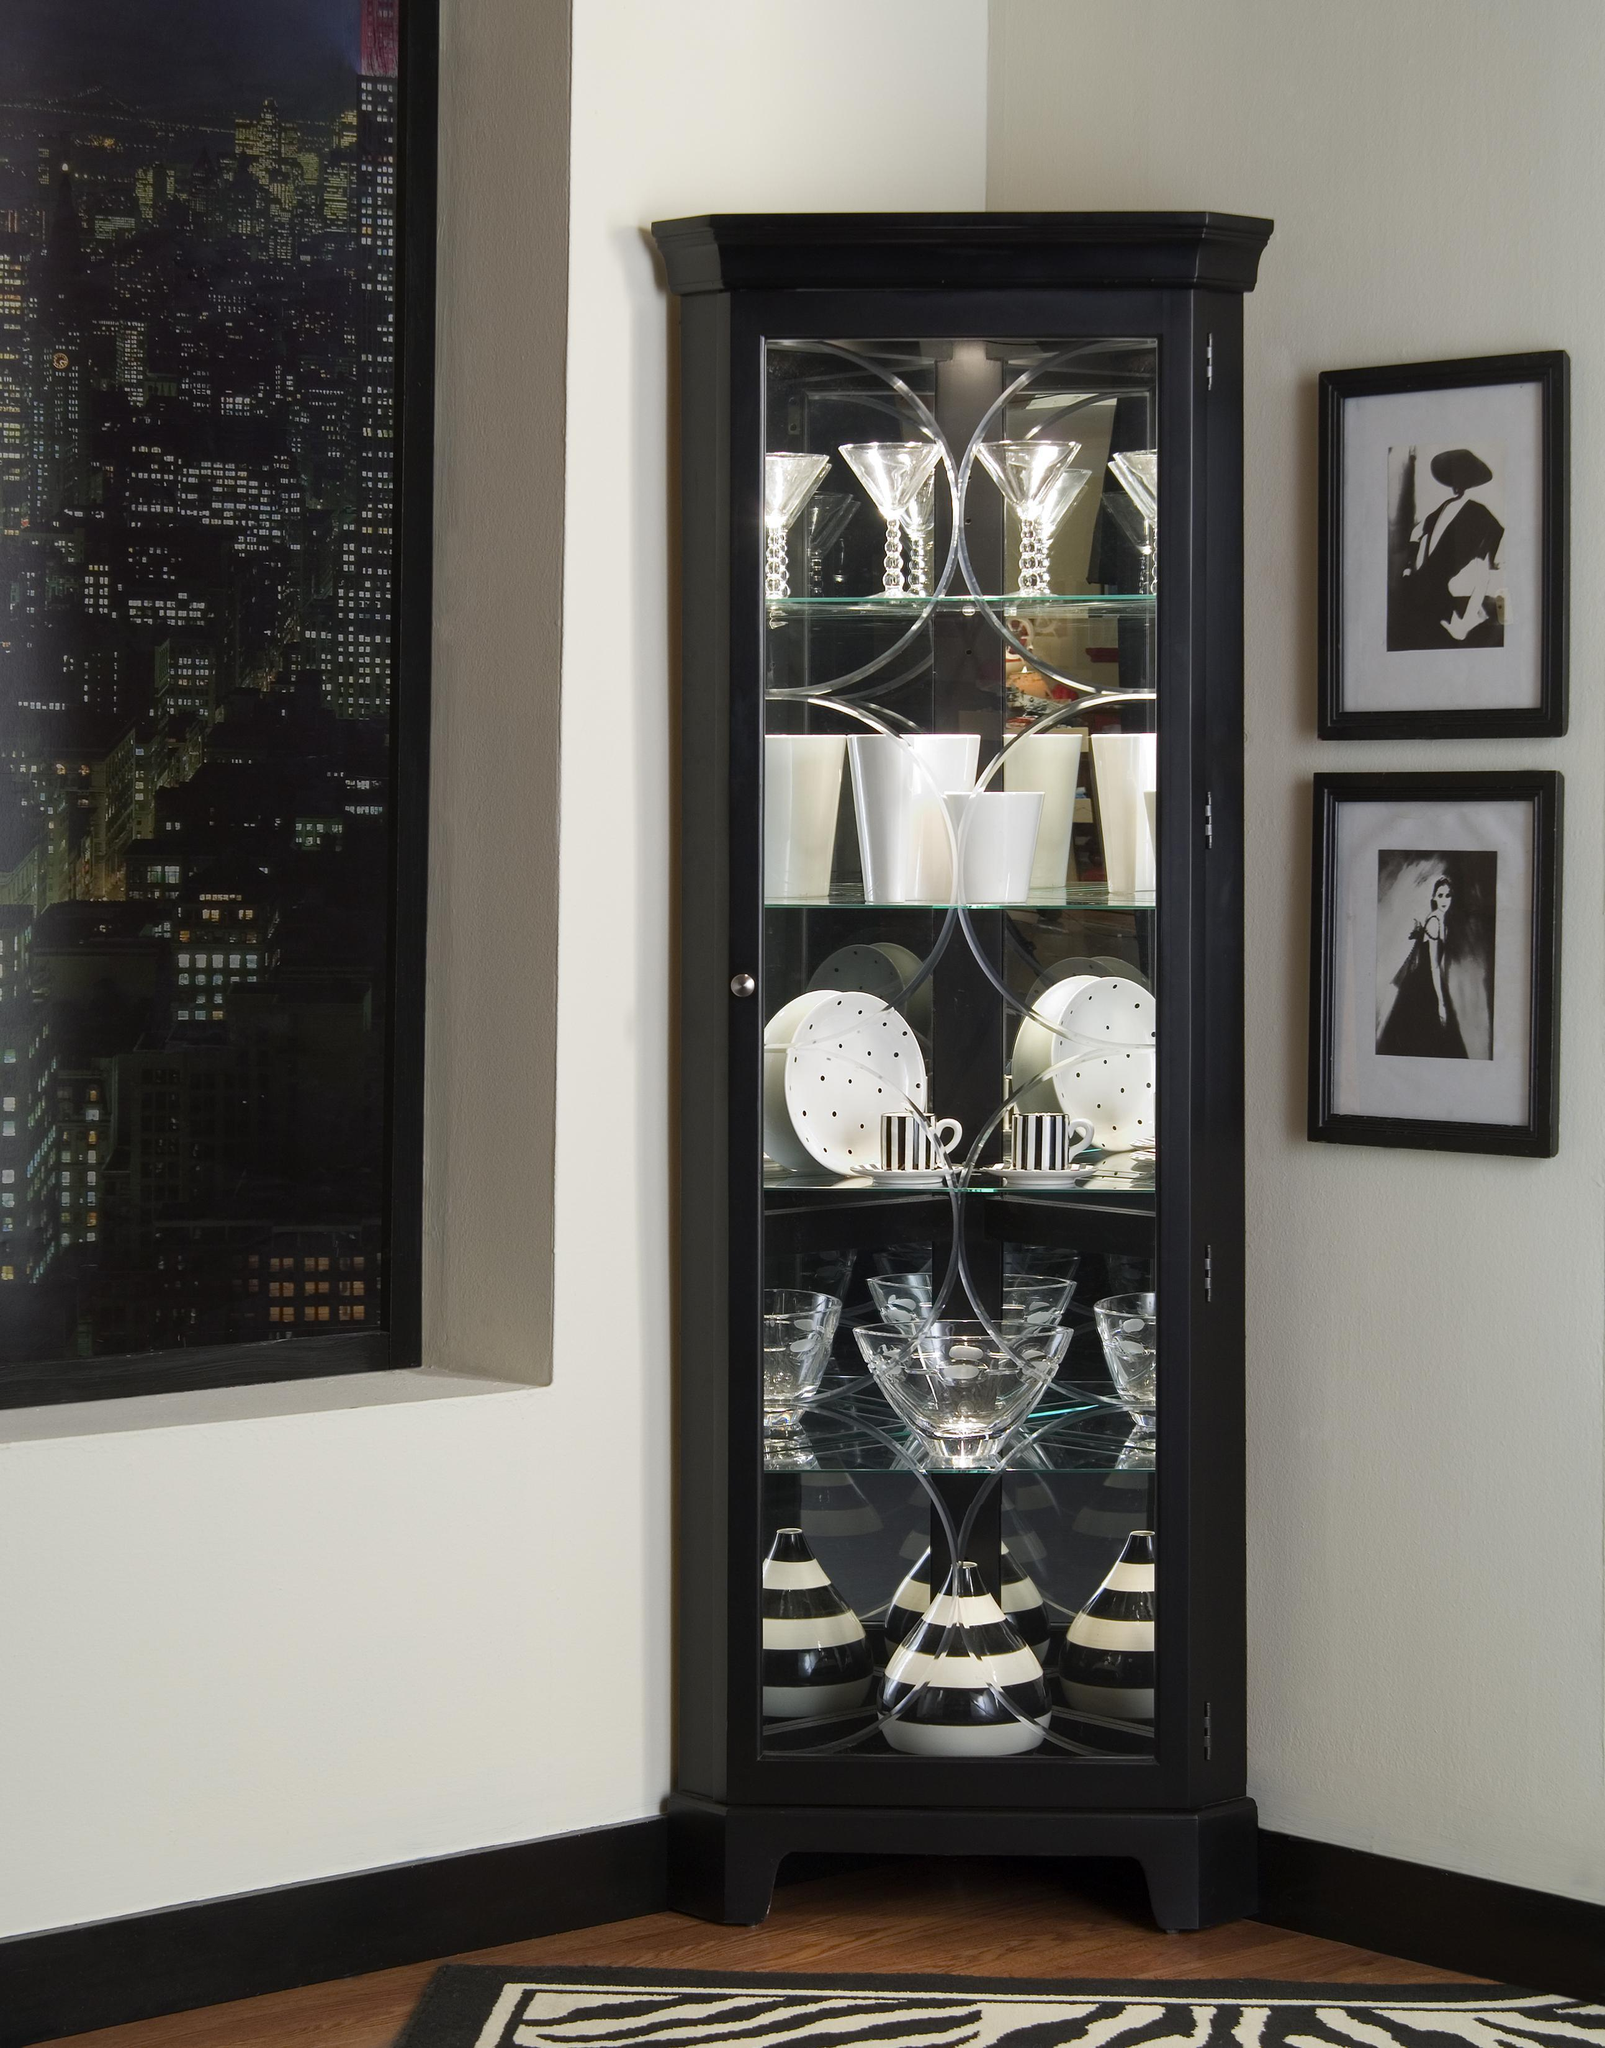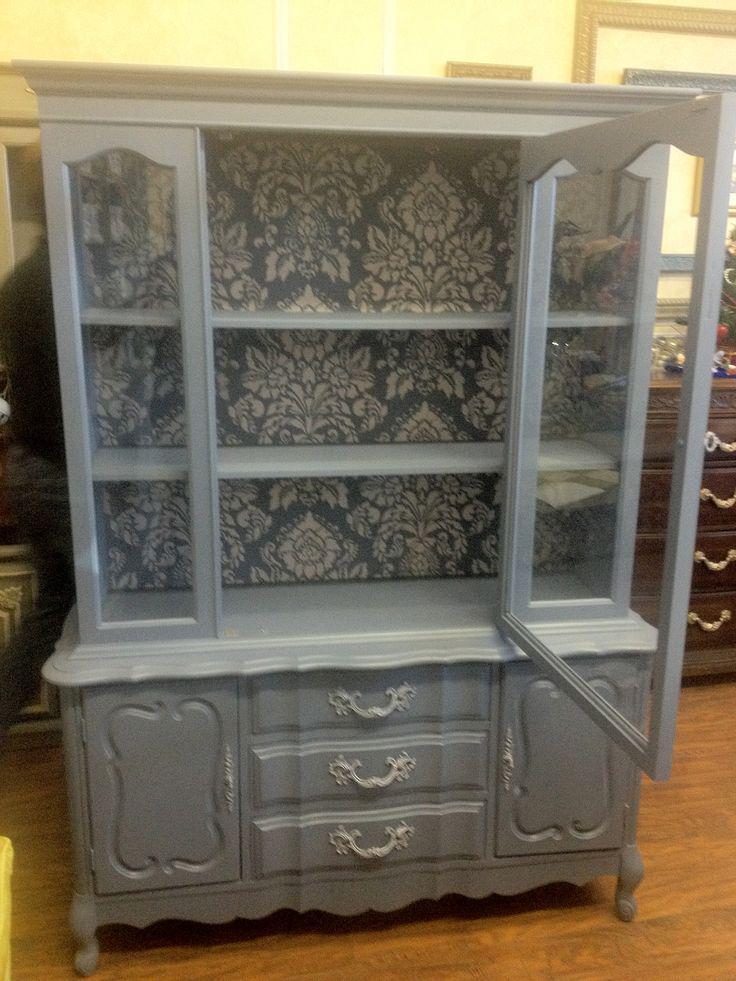The first image is the image on the left, the second image is the image on the right. Evaluate the accuracy of this statement regarding the images: "Two painted hutches both stand on legs with no glass in the bottom section, but are different colors, and one has a top curve design, while the other is flat on top.". Is it true? Answer yes or no. No. The first image is the image on the left, the second image is the image on the right. Examine the images to the left and right. Is the description "The cabinet in the left photo has a blue finish." accurate? Answer yes or no. No. 